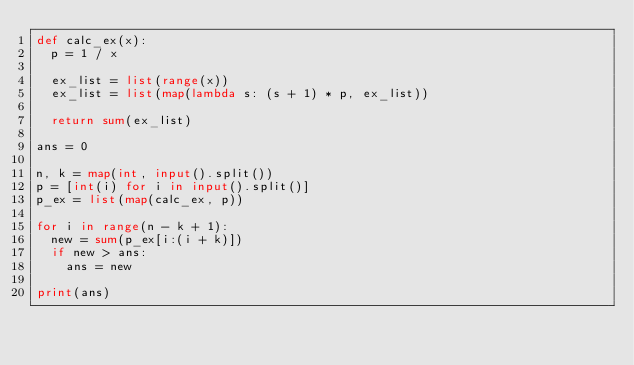<code> <loc_0><loc_0><loc_500><loc_500><_Python_>def calc_ex(x):
  p = 1 / x

  ex_list = list(range(x))
  ex_list = list(map(lambda s: (s + 1) * p, ex_list))

  return sum(ex_list)

ans = 0

n, k = map(int, input().split())
p = [int(i) for i in input().split()]
p_ex = list(map(calc_ex, p))

for i in range(n - k + 1):
  new = sum(p_ex[i:(i + k)])
  if new > ans:
    ans = new

print(ans)

</code> 